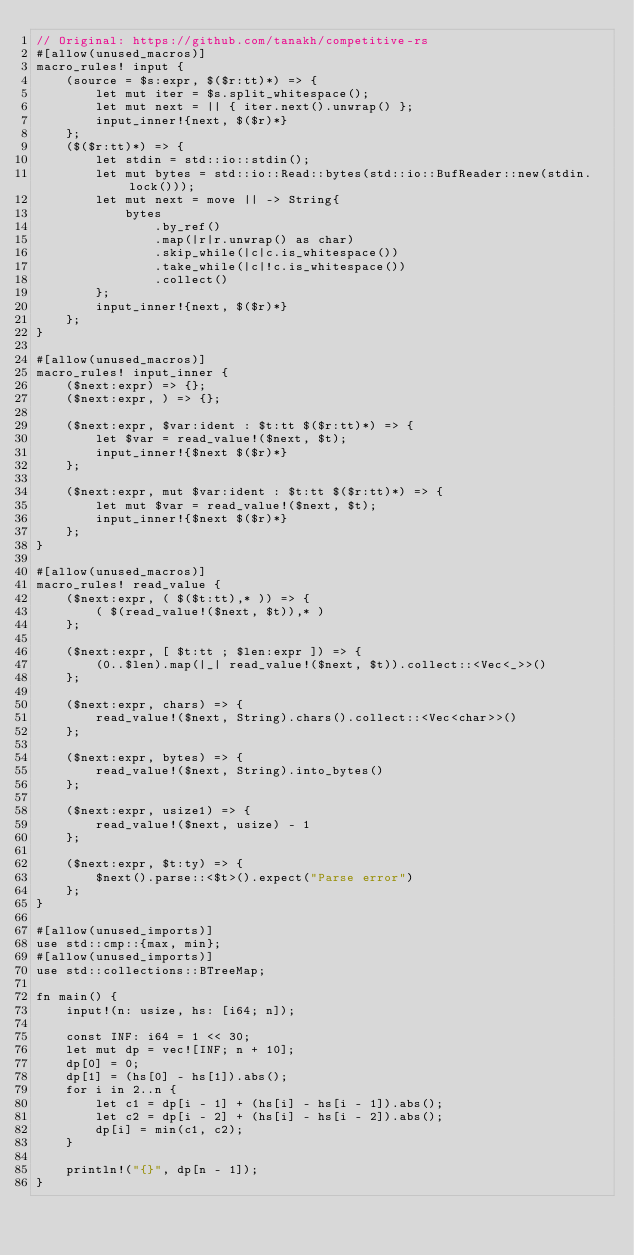<code> <loc_0><loc_0><loc_500><loc_500><_Rust_>// Original: https://github.com/tanakh/competitive-rs
#[allow(unused_macros)]
macro_rules! input {
    (source = $s:expr, $($r:tt)*) => {
        let mut iter = $s.split_whitespace();
        let mut next = || { iter.next().unwrap() };
        input_inner!{next, $($r)*}
    };
    ($($r:tt)*) => {
        let stdin = std::io::stdin();
        let mut bytes = std::io::Read::bytes(std::io::BufReader::new(stdin.lock()));
        let mut next = move || -> String{
            bytes
                .by_ref()
                .map(|r|r.unwrap() as char)
                .skip_while(|c|c.is_whitespace())
                .take_while(|c|!c.is_whitespace())
                .collect()
        };
        input_inner!{next, $($r)*}
    };
}

#[allow(unused_macros)]
macro_rules! input_inner {
    ($next:expr) => {};
    ($next:expr, ) => {};

    ($next:expr, $var:ident : $t:tt $($r:tt)*) => {
        let $var = read_value!($next, $t);
        input_inner!{$next $($r)*}
    };

    ($next:expr, mut $var:ident : $t:tt $($r:tt)*) => {
        let mut $var = read_value!($next, $t);
        input_inner!{$next $($r)*}
    };
}

#[allow(unused_macros)]
macro_rules! read_value {
    ($next:expr, ( $($t:tt),* )) => {
        ( $(read_value!($next, $t)),* )
    };

    ($next:expr, [ $t:tt ; $len:expr ]) => {
        (0..$len).map(|_| read_value!($next, $t)).collect::<Vec<_>>()
    };

    ($next:expr, chars) => {
        read_value!($next, String).chars().collect::<Vec<char>>()
    };

    ($next:expr, bytes) => {
        read_value!($next, String).into_bytes()
    };

    ($next:expr, usize1) => {
        read_value!($next, usize) - 1
    };

    ($next:expr, $t:ty) => {
        $next().parse::<$t>().expect("Parse error")
    };
}

#[allow(unused_imports)]
use std::cmp::{max, min};
#[allow(unused_imports)]
use std::collections::BTreeMap;

fn main() {
    input!(n: usize, hs: [i64; n]);

    const INF: i64 = 1 << 30;
    let mut dp = vec![INF; n + 10];
    dp[0] = 0;
    dp[1] = (hs[0] - hs[1]).abs();
    for i in 2..n {
        let c1 = dp[i - 1] + (hs[i] - hs[i - 1]).abs();
        let c2 = dp[i - 2] + (hs[i] - hs[i - 2]).abs();
        dp[i] = min(c1, c2);
    }

    println!("{}", dp[n - 1]);
}
</code> 